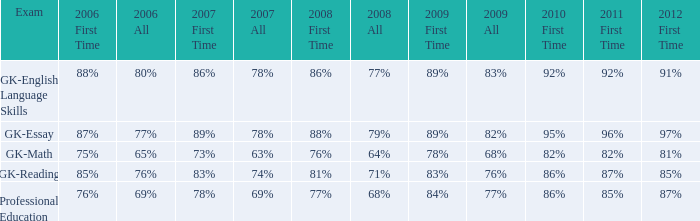What is the percentage for all in 2007 when all in 2006 was 65%? 63%. Would you mind parsing the complete table? {'header': ['Exam', '2006 First Time', '2006 All', '2007 First Time', '2007 All', '2008 First Time', '2008 All', '2009 First Time', '2009 All', '2010 First Time', '2011 First Time', '2012 First Time'], 'rows': [['GK-English Language Skills', '88%', '80%', '86%', '78%', '86%', '77%', '89%', '83%', '92%', '92%', '91%'], ['GK-Essay', '87%', '77%', '89%', '78%', '88%', '79%', '89%', '82%', '95%', '96%', '97%'], ['GK-Math', '75%', '65%', '73%', '63%', '76%', '64%', '78%', '68%', '82%', '82%', '81%'], ['GK-Reading', '85%', '76%', '83%', '74%', '81%', '71%', '83%', '76%', '86%', '87%', '85%'], ['Professional Education', '76%', '69%', '78%', '69%', '77%', '68%', '84%', '77%', '86%', '85%', '87%']]} 